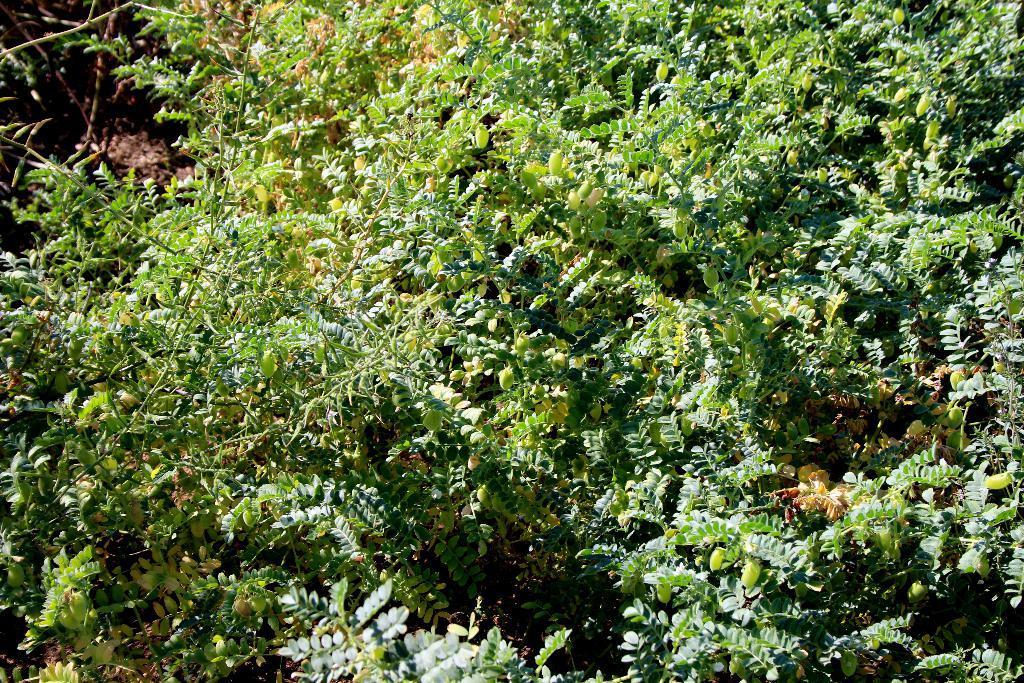Could you give a brief overview of what you see in this image? In this picture we can see few trees. 